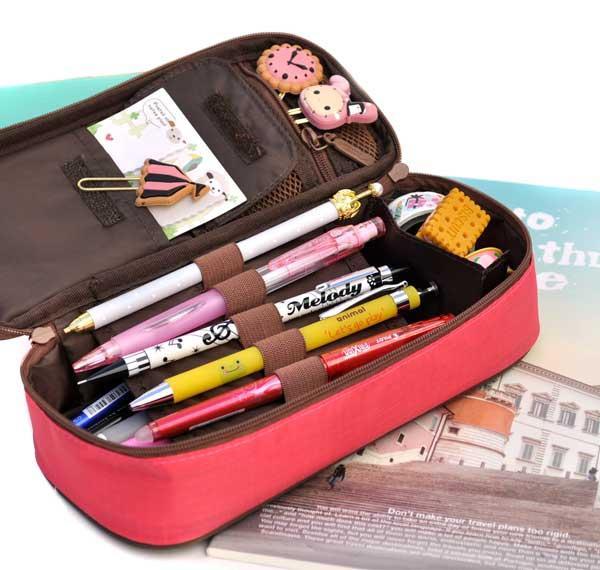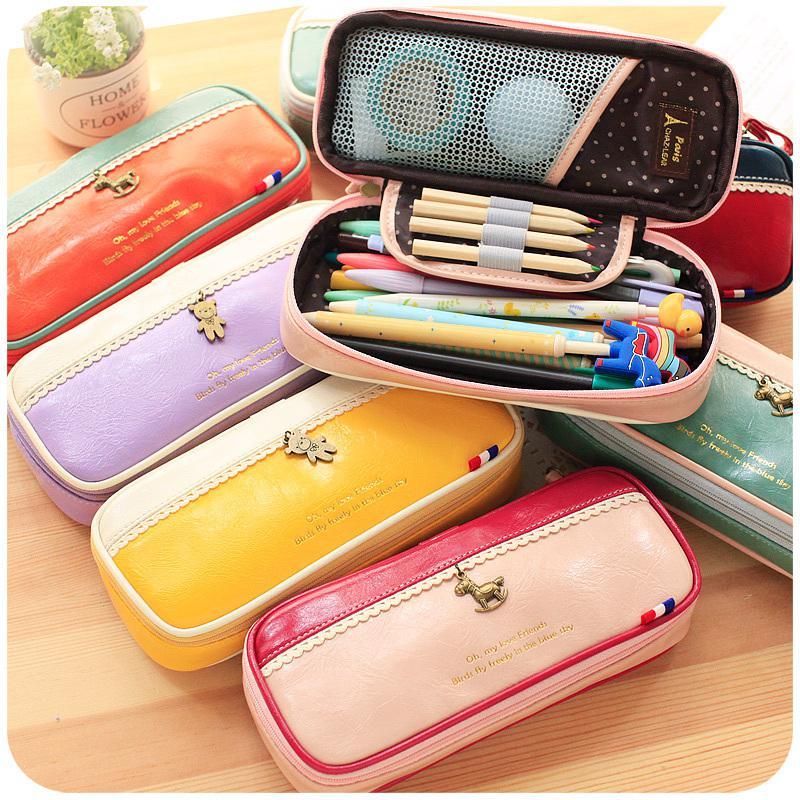The first image is the image on the left, the second image is the image on the right. For the images shown, is this caption "Left image shows an open blue case filled with writing supplies." true? Answer yes or no. No. 